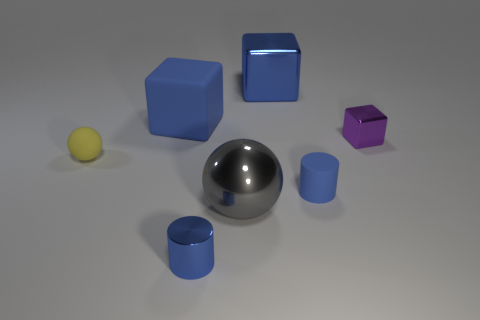Is there a cylinder that has the same material as the tiny yellow ball?
Make the answer very short. Yes. What is the material of the other cube that is the same size as the blue rubber block?
Provide a short and direct response. Metal. What number of tiny yellow things are the same shape as the big gray object?
Offer a terse response. 1. What is the size of the cube that is made of the same material as the tiny yellow sphere?
Keep it short and to the point. Large. There is a blue object that is to the right of the shiny cylinder and behind the tiny rubber sphere; what is its material?
Offer a terse response. Metal. What number of other spheres have the same size as the gray shiny sphere?
Offer a very short reply. 0. There is another big thing that is the same shape as the big blue rubber thing; what is it made of?
Ensure brevity in your answer.  Metal. How many things are matte objects right of the big blue matte object or blue matte things in front of the tiny yellow ball?
Your answer should be compact. 1. There is a big blue matte object; is its shape the same as the blue metallic object behind the tiny blue matte cylinder?
Your answer should be compact. Yes. The large blue rubber object that is to the left of the tiny object that is right of the small blue object that is on the right side of the small blue metal thing is what shape?
Your answer should be compact. Cube. 